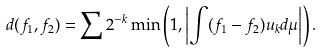<formula> <loc_0><loc_0><loc_500><loc_500>d ( f _ { 1 } , f _ { 2 } ) = \sum 2 ^ { - k } \min \left ( 1 , \left | \int ( f _ { 1 } - f _ { 2 } ) u _ { k } d \mu \right | \right ) .</formula> 